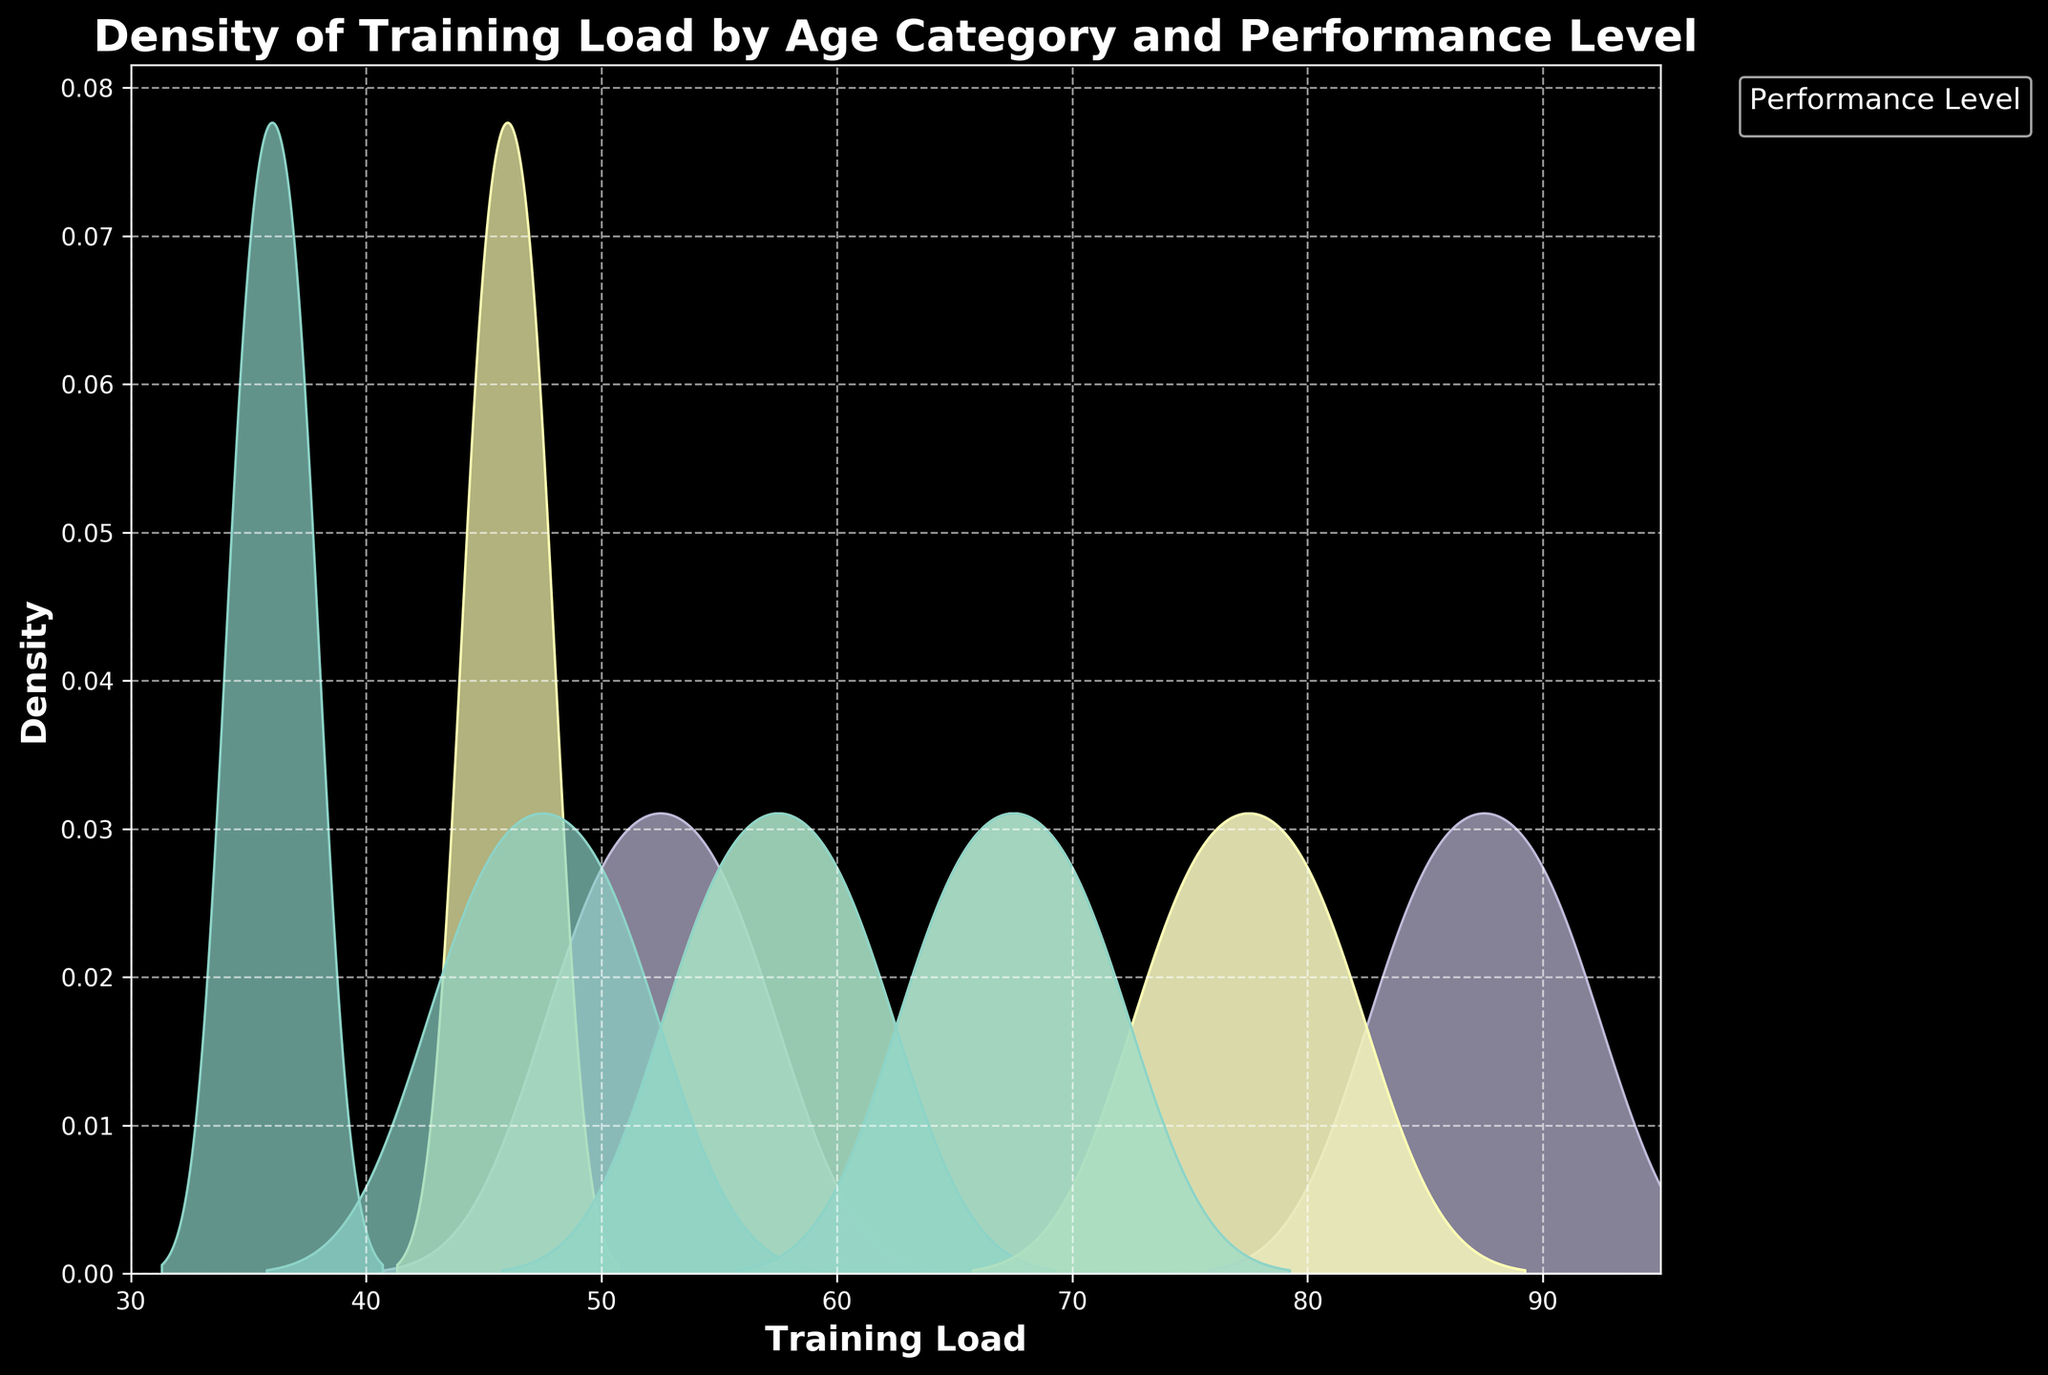What is the title of the figure? The title of the figure is located at the top of the plot. It describes what the figure is about.
Answer: Density of Training Load by Age Category and Performance Level What are the x-axis and y-axis labels? The x-axis and y-axis labels provide information about the variables being plotted. The x-axis represents 'Training Load,' and the y-axis represents 'Density.'
Answer: Training Load; Density Which age category has the highest density peak for the 'Advanced' performance level? To answer this, look at the density curves for each age category and identify the peak values for 'Advanced' performance level.
Answer: Senior How does the training load range vary across age categories? The training load range can be observed by looking at the spread of the density curves for each age category. U12 has a range from roughly 35 to 55, U15 from 45 to 70, U18 from 55 to 80, and Senior from 65 to 90.
Answer: It increases with age Compare the density peaks of the 'Intermediate' performance level between U15 and U18 age categories. Which has a higher peak? Observe the height of the density peaks for the 'Intermediate' performance level in the U15 and U18 age categories. U18 has a higher peak than U15 for 'Intermediate.'
Answer: U18 What is the overall trend in training load as the performance level increases within each age category? Observe the shift in the density curves from 'Beginner' to 'Advanced' within each age category. The training load shifts to the right, meaning an increase as the performance level increases.
Answer: The training load increases Which age category exhibits the most overlap in training load between different performance levels? Look at where the density curves overlap the most for each age category. U12 shows significant overlap across 'Beginner,' 'Intermediate,' and 'Advanced' performance levels.
Answer: U12 How does the density curve for 'Beginner' performance level in the Senior category compare to the 'Advanced' level in the U12 category? Compare the density curves at the 'Training Load' for the 'Beginner' level in the Senior category and the 'Advanced' level in the U12 category. The 'Beginner' in Senior has a higher training load and a broader curve than 'Advanced' in U12, indicating a significant difference in load.
Answer: Higher and broader Which age category and performance level combination has the narrowest spread? Look for the density curve with the narrowest spread (the least variability) for any combination of age category and performance level. Senior category with 'Advanced' level has the narrowest spread.
Answer: Senior 'Advanced' 